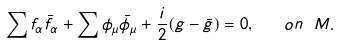Convert formula to latex. <formula><loc_0><loc_0><loc_500><loc_500>\sum f _ { \alpha } \bar { f } _ { \alpha } + \sum \phi _ { \mu } \bar { \phi } _ { \mu } + \frac { i } { 2 } ( g - \bar { g } ) = 0 , \quad o n \ M .</formula> 